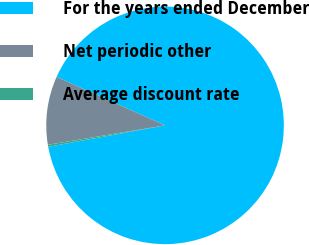Convert chart. <chart><loc_0><loc_0><loc_500><loc_500><pie_chart><fcel>For the years ended December<fcel>Net periodic other<fcel>Average discount rate<nl><fcel>90.42%<fcel>9.3%<fcel>0.28%<nl></chart> 